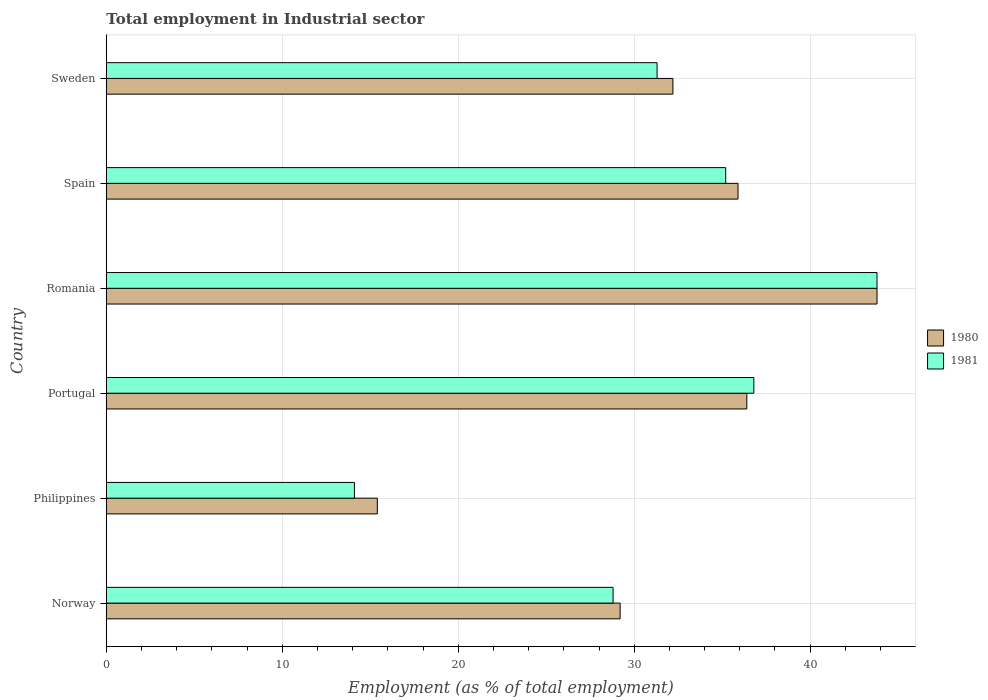Are the number of bars per tick equal to the number of legend labels?
Your response must be concise. Yes. Are the number of bars on each tick of the Y-axis equal?
Give a very brief answer. Yes. What is the label of the 3rd group of bars from the top?
Keep it short and to the point. Romania. What is the employment in industrial sector in 1980 in Romania?
Offer a terse response. 43.8. Across all countries, what is the maximum employment in industrial sector in 1980?
Give a very brief answer. 43.8. Across all countries, what is the minimum employment in industrial sector in 1981?
Ensure brevity in your answer.  14.1. In which country was the employment in industrial sector in 1980 maximum?
Offer a very short reply. Romania. In which country was the employment in industrial sector in 1981 minimum?
Offer a very short reply. Philippines. What is the total employment in industrial sector in 1981 in the graph?
Make the answer very short. 190. What is the difference between the employment in industrial sector in 1980 in Norway and that in Sweden?
Offer a very short reply. -3. What is the difference between the employment in industrial sector in 1980 in Romania and the employment in industrial sector in 1981 in Norway?
Keep it short and to the point. 15. What is the average employment in industrial sector in 1981 per country?
Keep it short and to the point. 31.67. What is the difference between the employment in industrial sector in 1981 and employment in industrial sector in 1980 in Portugal?
Provide a succinct answer. 0.4. In how many countries, is the employment in industrial sector in 1981 greater than 28 %?
Offer a terse response. 5. What is the ratio of the employment in industrial sector in 1980 in Norway to that in Sweden?
Your response must be concise. 0.91. Is the difference between the employment in industrial sector in 1981 in Norway and Philippines greater than the difference between the employment in industrial sector in 1980 in Norway and Philippines?
Give a very brief answer. Yes. What is the difference between the highest and the lowest employment in industrial sector in 1980?
Offer a terse response. 28.4. Is the sum of the employment in industrial sector in 1980 in Philippines and Portugal greater than the maximum employment in industrial sector in 1981 across all countries?
Your answer should be compact. Yes. How many bars are there?
Give a very brief answer. 12. Are all the bars in the graph horizontal?
Your response must be concise. Yes. What is the difference between two consecutive major ticks on the X-axis?
Make the answer very short. 10. Are the values on the major ticks of X-axis written in scientific E-notation?
Give a very brief answer. No. Where does the legend appear in the graph?
Provide a succinct answer. Center right. What is the title of the graph?
Your response must be concise. Total employment in Industrial sector. Does "1991" appear as one of the legend labels in the graph?
Your answer should be very brief. No. What is the label or title of the X-axis?
Your answer should be compact. Employment (as % of total employment). What is the label or title of the Y-axis?
Your answer should be very brief. Country. What is the Employment (as % of total employment) in 1980 in Norway?
Offer a terse response. 29.2. What is the Employment (as % of total employment) of 1981 in Norway?
Your answer should be compact. 28.8. What is the Employment (as % of total employment) in 1980 in Philippines?
Keep it short and to the point. 15.4. What is the Employment (as % of total employment) of 1981 in Philippines?
Your answer should be very brief. 14.1. What is the Employment (as % of total employment) of 1980 in Portugal?
Your answer should be very brief. 36.4. What is the Employment (as % of total employment) in 1981 in Portugal?
Offer a terse response. 36.8. What is the Employment (as % of total employment) in 1980 in Romania?
Keep it short and to the point. 43.8. What is the Employment (as % of total employment) in 1981 in Romania?
Ensure brevity in your answer.  43.8. What is the Employment (as % of total employment) of 1980 in Spain?
Keep it short and to the point. 35.9. What is the Employment (as % of total employment) in 1981 in Spain?
Offer a very short reply. 35.2. What is the Employment (as % of total employment) in 1980 in Sweden?
Give a very brief answer. 32.2. What is the Employment (as % of total employment) in 1981 in Sweden?
Make the answer very short. 31.3. Across all countries, what is the maximum Employment (as % of total employment) in 1980?
Offer a very short reply. 43.8. Across all countries, what is the maximum Employment (as % of total employment) in 1981?
Provide a succinct answer. 43.8. Across all countries, what is the minimum Employment (as % of total employment) of 1980?
Offer a very short reply. 15.4. Across all countries, what is the minimum Employment (as % of total employment) in 1981?
Give a very brief answer. 14.1. What is the total Employment (as % of total employment) in 1980 in the graph?
Offer a very short reply. 192.9. What is the total Employment (as % of total employment) of 1981 in the graph?
Provide a succinct answer. 190. What is the difference between the Employment (as % of total employment) in 1980 in Norway and that in Romania?
Provide a short and direct response. -14.6. What is the difference between the Employment (as % of total employment) in 1980 in Norway and that in Spain?
Make the answer very short. -6.7. What is the difference between the Employment (as % of total employment) in 1981 in Norway and that in Sweden?
Make the answer very short. -2.5. What is the difference between the Employment (as % of total employment) of 1981 in Philippines and that in Portugal?
Offer a terse response. -22.7. What is the difference between the Employment (as % of total employment) in 1980 in Philippines and that in Romania?
Provide a short and direct response. -28.4. What is the difference between the Employment (as % of total employment) in 1981 in Philippines and that in Romania?
Your answer should be very brief. -29.7. What is the difference between the Employment (as % of total employment) of 1980 in Philippines and that in Spain?
Offer a very short reply. -20.5. What is the difference between the Employment (as % of total employment) in 1981 in Philippines and that in Spain?
Provide a succinct answer. -21.1. What is the difference between the Employment (as % of total employment) in 1980 in Philippines and that in Sweden?
Provide a short and direct response. -16.8. What is the difference between the Employment (as % of total employment) in 1981 in Philippines and that in Sweden?
Your answer should be compact. -17.2. What is the difference between the Employment (as % of total employment) of 1980 in Portugal and that in Romania?
Offer a terse response. -7.4. What is the difference between the Employment (as % of total employment) of 1981 in Portugal and that in Romania?
Your response must be concise. -7. What is the difference between the Employment (as % of total employment) of 1980 in Portugal and that in Spain?
Your response must be concise. 0.5. What is the difference between the Employment (as % of total employment) of 1980 in Romania and that in Spain?
Provide a succinct answer. 7.9. What is the difference between the Employment (as % of total employment) of 1981 in Romania and that in Spain?
Your answer should be very brief. 8.6. What is the difference between the Employment (as % of total employment) in 1981 in Romania and that in Sweden?
Offer a very short reply. 12.5. What is the difference between the Employment (as % of total employment) in 1980 in Norway and the Employment (as % of total employment) in 1981 in Philippines?
Keep it short and to the point. 15.1. What is the difference between the Employment (as % of total employment) in 1980 in Norway and the Employment (as % of total employment) in 1981 in Romania?
Ensure brevity in your answer.  -14.6. What is the difference between the Employment (as % of total employment) in 1980 in Norway and the Employment (as % of total employment) in 1981 in Spain?
Provide a short and direct response. -6. What is the difference between the Employment (as % of total employment) of 1980 in Philippines and the Employment (as % of total employment) of 1981 in Portugal?
Your answer should be compact. -21.4. What is the difference between the Employment (as % of total employment) of 1980 in Philippines and the Employment (as % of total employment) of 1981 in Romania?
Ensure brevity in your answer.  -28.4. What is the difference between the Employment (as % of total employment) in 1980 in Philippines and the Employment (as % of total employment) in 1981 in Spain?
Give a very brief answer. -19.8. What is the difference between the Employment (as % of total employment) in 1980 in Philippines and the Employment (as % of total employment) in 1981 in Sweden?
Your answer should be very brief. -15.9. What is the difference between the Employment (as % of total employment) in 1980 in Portugal and the Employment (as % of total employment) in 1981 in Romania?
Offer a very short reply. -7.4. What is the difference between the Employment (as % of total employment) of 1980 in Portugal and the Employment (as % of total employment) of 1981 in Sweden?
Provide a succinct answer. 5.1. What is the difference between the Employment (as % of total employment) in 1980 in Spain and the Employment (as % of total employment) in 1981 in Sweden?
Offer a terse response. 4.6. What is the average Employment (as % of total employment) of 1980 per country?
Give a very brief answer. 32.15. What is the average Employment (as % of total employment) in 1981 per country?
Offer a terse response. 31.67. What is the difference between the Employment (as % of total employment) in 1980 and Employment (as % of total employment) in 1981 in Philippines?
Make the answer very short. 1.3. What is the difference between the Employment (as % of total employment) of 1980 and Employment (as % of total employment) of 1981 in Romania?
Offer a terse response. 0. What is the difference between the Employment (as % of total employment) of 1980 and Employment (as % of total employment) of 1981 in Spain?
Your response must be concise. 0.7. What is the ratio of the Employment (as % of total employment) of 1980 in Norway to that in Philippines?
Your response must be concise. 1.9. What is the ratio of the Employment (as % of total employment) in 1981 in Norway to that in Philippines?
Ensure brevity in your answer.  2.04. What is the ratio of the Employment (as % of total employment) of 1980 in Norway to that in Portugal?
Your answer should be very brief. 0.8. What is the ratio of the Employment (as % of total employment) of 1981 in Norway to that in Portugal?
Ensure brevity in your answer.  0.78. What is the ratio of the Employment (as % of total employment) of 1980 in Norway to that in Romania?
Give a very brief answer. 0.67. What is the ratio of the Employment (as % of total employment) of 1981 in Norway to that in Romania?
Offer a very short reply. 0.66. What is the ratio of the Employment (as % of total employment) of 1980 in Norway to that in Spain?
Provide a succinct answer. 0.81. What is the ratio of the Employment (as % of total employment) in 1981 in Norway to that in Spain?
Your answer should be compact. 0.82. What is the ratio of the Employment (as % of total employment) in 1980 in Norway to that in Sweden?
Your answer should be very brief. 0.91. What is the ratio of the Employment (as % of total employment) of 1981 in Norway to that in Sweden?
Give a very brief answer. 0.92. What is the ratio of the Employment (as % of total employment) of 1980 in Philippines to that in Portugal?
Offer a very short reply. 0.42. What is the ratio of the Employment (as % of total employment) in 1981 in Philippines to that in Portugal?
Keep it short and to the point. 0.38. What is the ratio of the Employment (as % of total employment) in 1980 in Philippines to that in Romania?
Your response must be concise. 0.35. What is the ratio of the Employment (as % of total employment) in 1981 in Philippines to that in Romania?
Ensure brevity in your answer.  0.32. What is the ratio of the Employment (as % of total employment) in 1980 in Philippines to that in Spain?
Provide a short and direct response. 0.43. What is the ratio of the Employment (as % of total employment) of 1981 in Philippines to that in Spain?
Offer a very short reply. 0.4. What is the ratio of the Employment (as % of total employment) of 1980 in Philippines to that in Sweden?
Ensure brevity in your answer.  0.48. What is the ratio of the Employment (as % of total employment) of 1981 in Philippines to that in Sweden?
Offer a terse response. 0.45. What is the ratio of the Employment (as % of total employment) of 1980 in Portugal to that in Romania?
Give a very brief answer. 0.83. What is the ratio of the Employment (as % of total employment) of 1981 in Portugal to that in Romania?
Ensure brevity in your answer.  0.84. What is the ratio of the Employment (as % of total employment) in 1980 in Portugal to that in Spain?
Ensure brevity in your answer.  1.01. What is the ratio of the Employment (as % of total employment) in 1981 in Portugal to that in Spain?
Your answer should be compact. 1.05. What is the ratio of the Employment (as % of total employment) of 1980 in Portugal to that in Sweden?
Ensure brevity in your answer.  1.13. What is the ratio of the Employment (as % of total employment) of 1981 in Portugal to that in Sweden?
Keep it short and to the point. 1.18. What is the ratio of the Employment (as % of total employment) of 1980 in Romania to that in Spain?
Your answer should be very brief. 1.22. What is the ratio of the Employment (as % of total employment) of 1981 in Romania to that in Spain?
Keep it short and to the point. 1.24. What is the ratio of the Employment (as % of total employment) in 1980 in Romania to that in Sweden?
Keep it short and to the point. 1.36. What is the ratio of the Employment (as % of total employment) in 1981 in Romania to that in Sweden?
Give a very brief answer. 1.4. What is the ratio of the Employment (as % of total employment) of 1980 in Spain to that in Sweden?
Your answer should be very brief. 1.11. What is the ratio of the Employment (as % of total employment) in 1981 in Spain to that in Sweden?
Provide a short and direct response. 1.12. What is the difference between the highest and the second highest Employment (as % of total employment) of 1980?
Make the answer very short. 7.4. What is the difference between the highest and the second highest Employment (as % of total employment) in 1981?
Give a very brief answer. 7. What is the difference between the highest and the lowest Employment (as % of total employment) in 1980?
Offer a very short reply. 28.4. What is the difference between the highest and the lowest Employment (as % of total employment) in 1981?
Give a very brief answer. 29.7. 